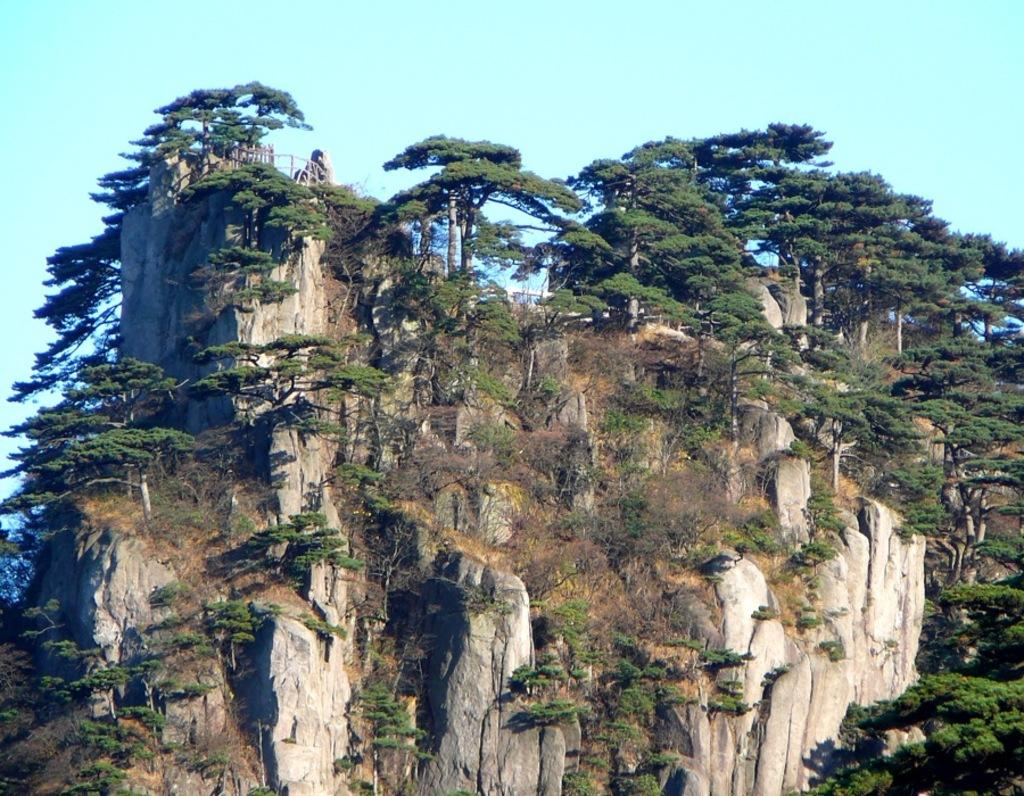What is the main subject of the image? The main subject of the image is a mountain. What can be seen on the mountain in the image? There are trees on the mountain in the image. Where is the mountain located in the image? The mountain is in the middle of the image. What is visible in the background of the image? The sky is visible in the background of the image. How many apples can be seen in the image? There are no apples present in the image. What color are the eyes of the person in the image? There is no person present in the image, so there are no eyes to describe. 